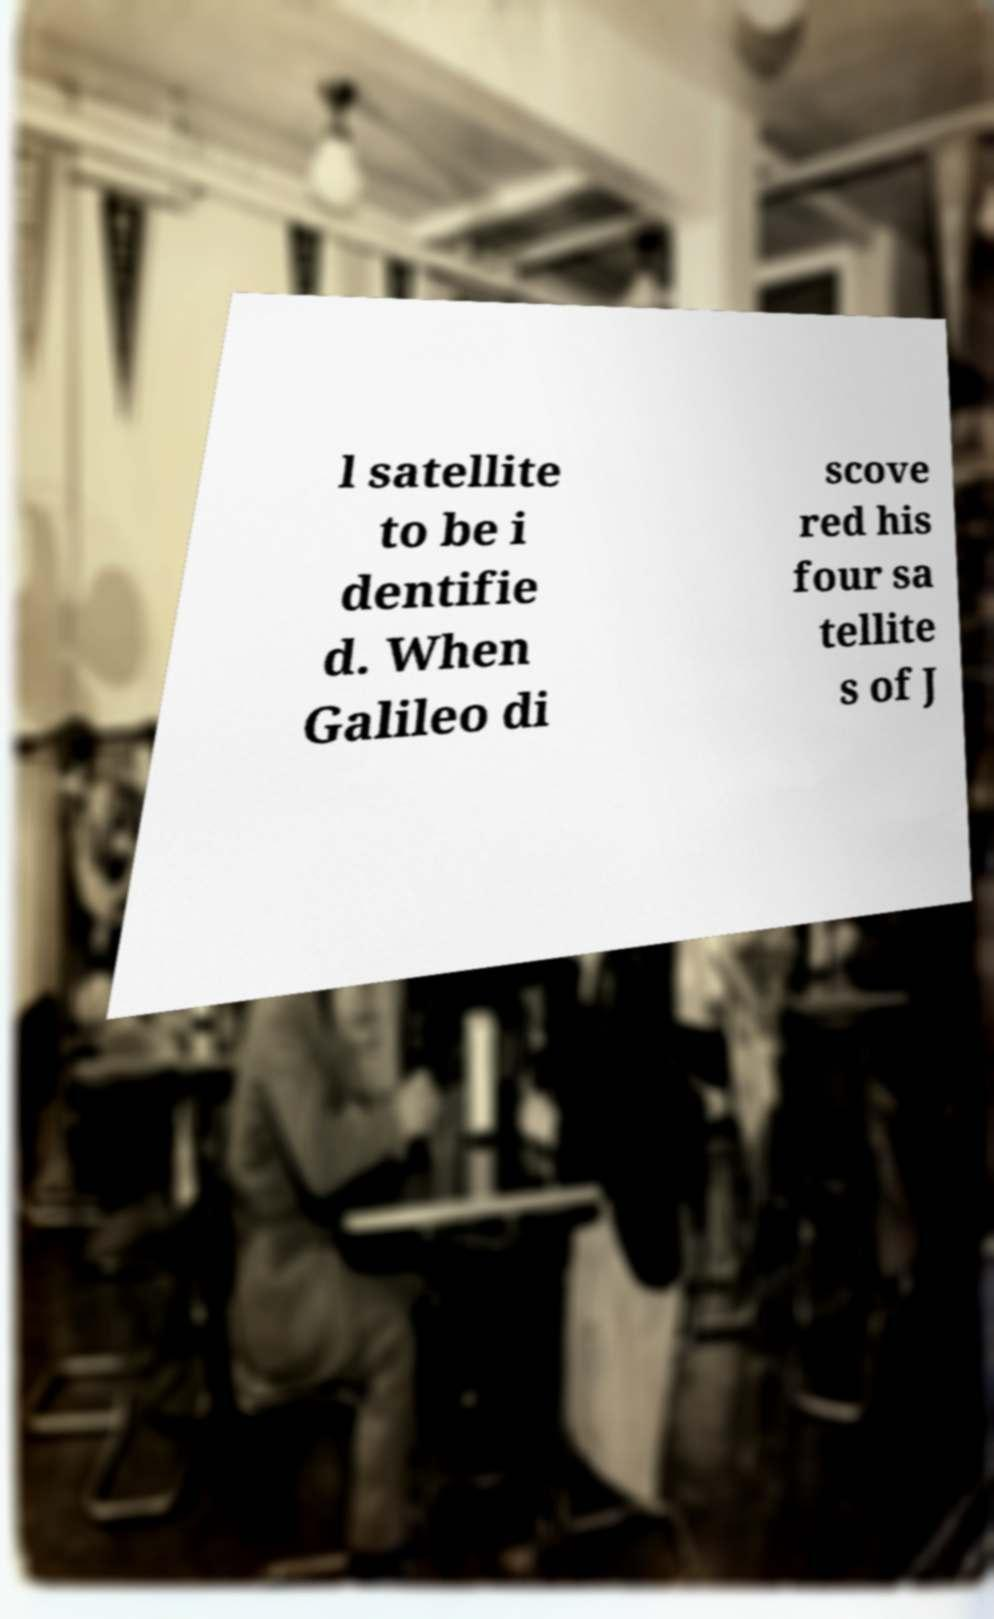Could you extract and type out the text from this image? l satellite to be i dentifie d. When Galileo di scove red his four sa tellite s of J 